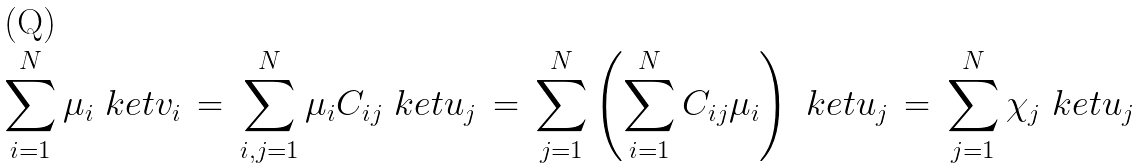<formula> <loc_0><loc_0><loc_500><loc_500>\sum _ { i = 1 } ^ { N } \mu _ { i } \ k e t { v _ { i } } \, = \, \sum _ { i , j = 1 } ^ { N } \mu _ { i } C _ { i j } \ k e t { u _ { j } } \, = \, \sum _ { j = 1 } ^ { N } \left ( \sum _ { i = 1 } ^ { N } C _ { i j } \mu _ { i } \right ) \ k e t { u _ { j } } \, = \, \sum _ { j = 1 } ^ { N } \chi _ { j } \ k e t { u _ { j } }</formula> 